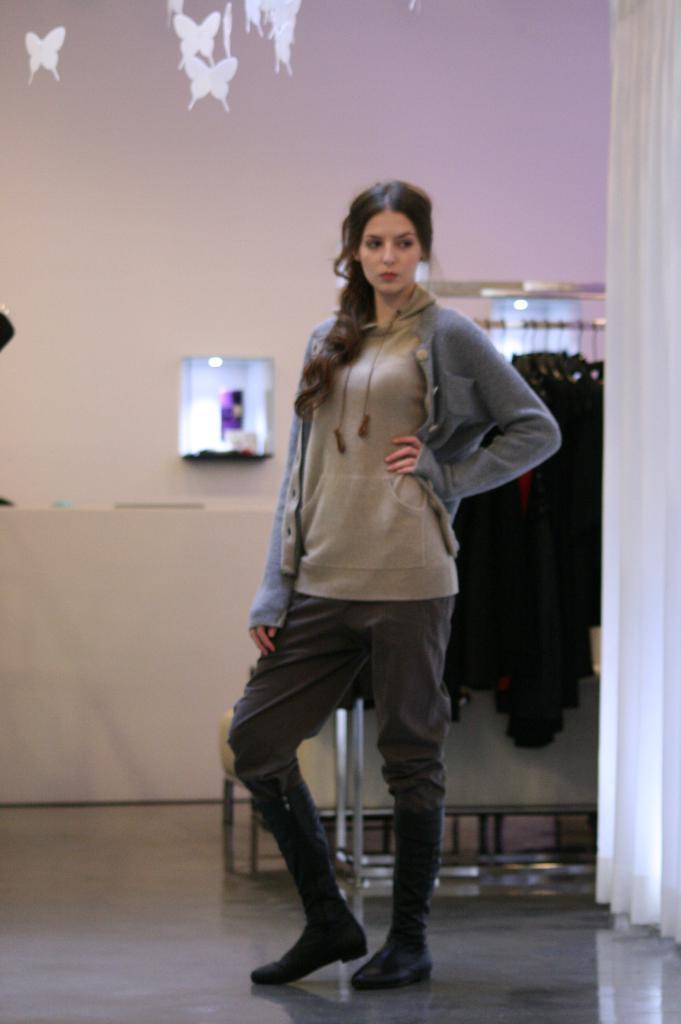Could you give a brief overview of what you see in this image? In this image we can see a lady standing. In the back we can see a stand. Also there are dresses hung. In the background there is a wall with an object. Also we can see wallpaper of butterflies on the wall. On the right side there is curtain. 